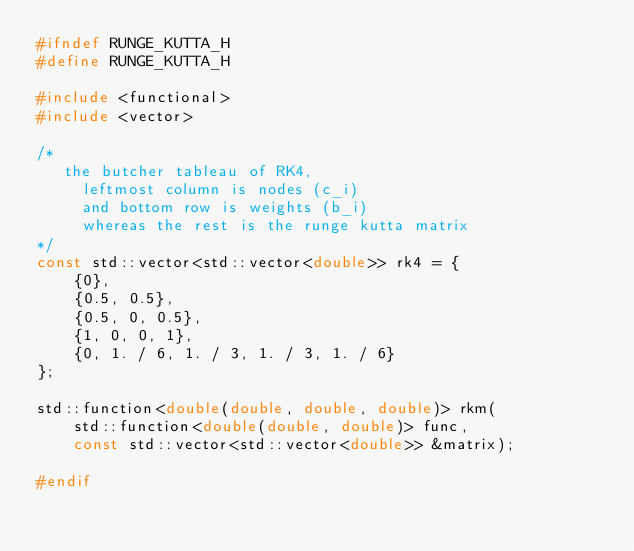Convert code to text. <code><loc_0><loc_0><loc_500><loc_500><_C_>#ifndef RUNGE_KUTTA_H
#define RUNGE_KUTTA_H

#include <functional>
#include <vector>

/*
   the butcher tableau of RK4,
     leftmost column is nodes (c_i)
     and bottom row is weights (b_i)
     whereas the rest is the runge kutta matrix
*/
const std::vector<std::vector<double>> rk4 = {
    {0},
    {0.5, 0.5},
    {0.5, 0, 0.5},
    {1, 0, 0, 1},
    {0, 1. / 6, 1. / 3, 1. / 3, 1. / 6}
};

std::function<double(double, double, double)> rkm(
    std::function<double(double, double)> func,
    const std::vector<std::vector<double>> &matrix);

#endif</code> 